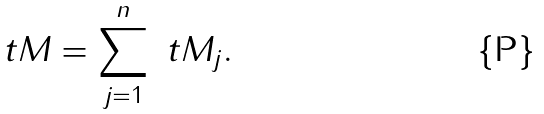<formula> <loc_0><loc_0><loc_500><loc_500>\ t M = \sum _ { j = 1 } ^ { n } \ t M _ { j } .</formula> 